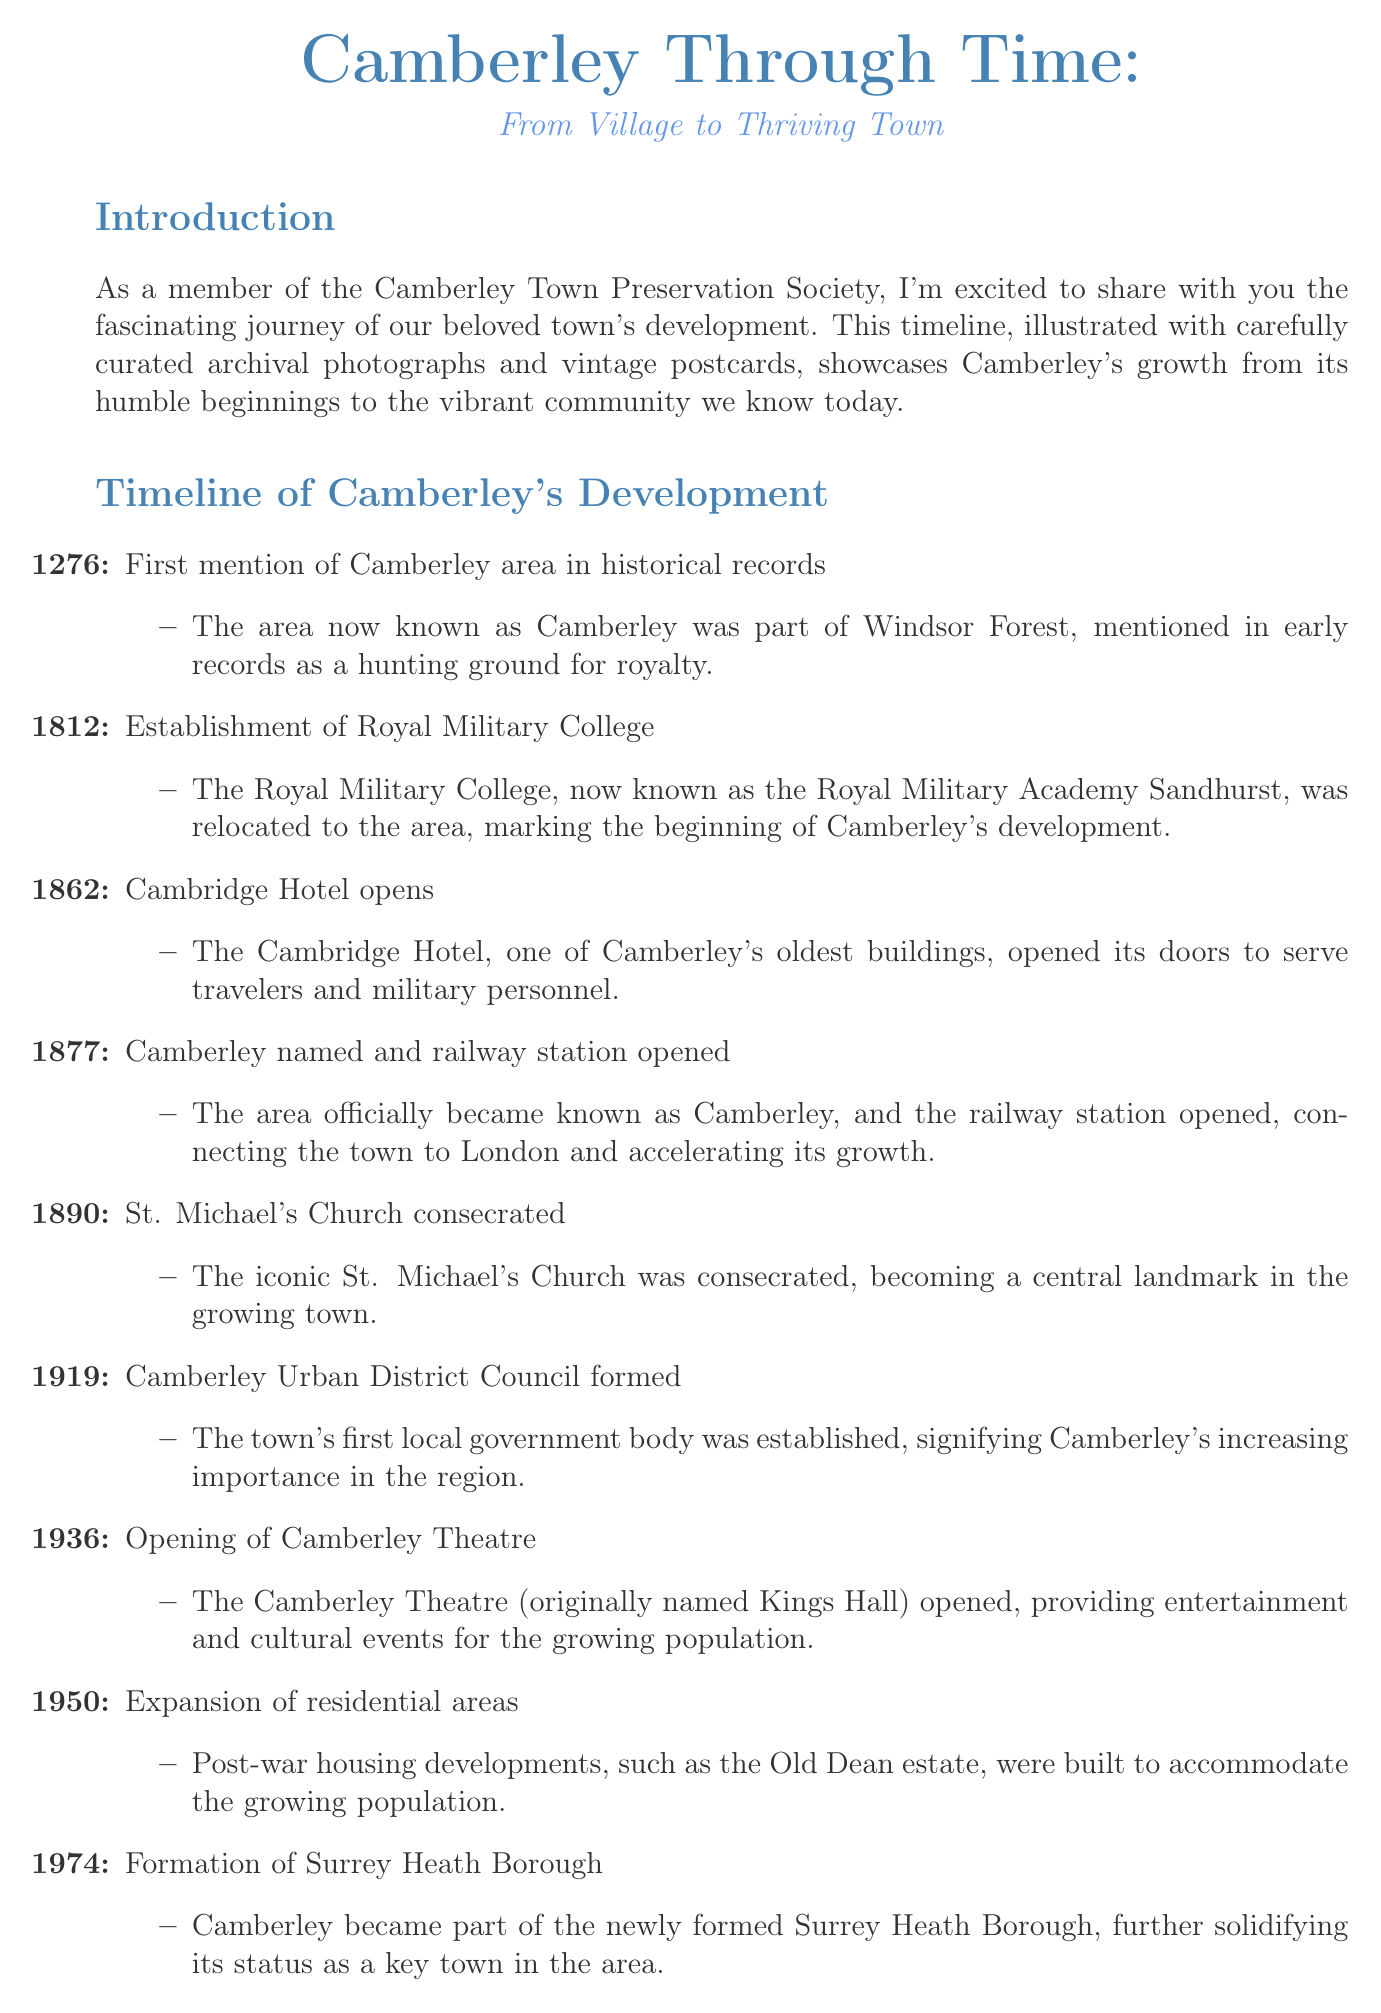what year was Camberley first mentioned in historical records? The first mention of Camberley was recorded in the year 1276.
Answer: 1276 what significant establishment was relocated to Camberley in 1812? The establishment that was relocated is the Royal Military College, which is now known as the Royal Military Academy Sandhurst.
Answer: Royal Military College when did the Cambridge Hotel open? The Cambridge Hotel opened in the year 1862.
Answer: 1862 what was the original name of the Camberley Theatre when it opened in 1936? The original name of the Camberley Theatre was Kings Hall.
Answer: Kings Hall what event in 1919 marked an important local governance milestone for Camberley? The formation of the Camberley Urban District Council was a significant governance event in 1919.
Answer: Camberley Urban District Council formed how did the opening of the railway station in 1877 impact Camberley? The opening of the railway station connected Camberley to London and accelerated its growth.
Answer: Accelerating its growth what was the purpose of the town center regeneration project initiated in 2020? The project involved significant improvements such as the refurbishment of the High Street and Princess Way.
Answer: Refurbishment of the High Street and Princess Way what is the website for the Camberley Town Preservation Society? The website where people can learn more about the preservation efforts is provided in the newsletter.
Answer: www.camberleypreservation.org 